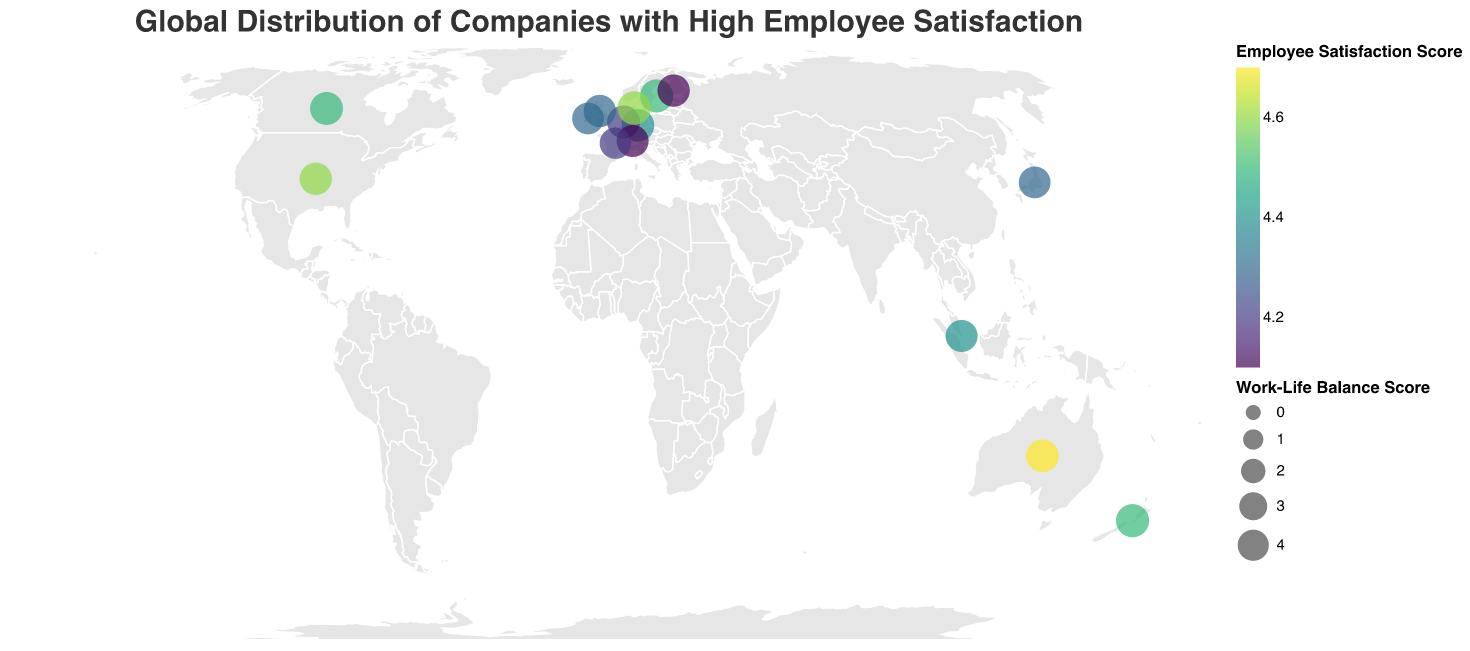What is the title of the figure? The title is typically located at the top of the plot, clearly describing the subject of the figure. Here, the title reads "Global Distribution of Companies with High Employee Satisfaction."
Answer: Global Distribution of Companies with High Employee Satisfaction How many companies are plotted in the figure? By counting the number of circles on the figure, we notice each circle represents a different company. There are 15 companies plotted in the figure.
Answer: 15 Which company has the highest Employee Satisfaction Score and what is that score? By checking the legend and color coding, we can identify that Atlassian in Australia has the highest Employee Satisfaction Score, indicated by the darkest color. The score is 4.7.
Answer: Atlassian, 4.7 Which company has the best Work-Life Balance Score and what is that score? By observing the size of the circles, we see that Lego in Denmark has the largest circle, representing the highest Work-Life Balance Score of 4.8.
Answer: Lego, 4.8 Compare the Employee Satisfaction Scores between Google and Spotify. Which one is higher? By referring to the colors of the circles for these two companies, we see that Google's circle is slightly darker than Spotify's, indicating a higher Employee Satisfaction Score. Google's score is 4.6, and Spotify's score is 4.5.
Answer: Google, 4.6 > 4.5 Which continent has the highest number of companies with high employee satisfaction as shown in the figure? By examining the geographic locations of the plotted companies, we observe that Europe has the most companies listed, with a total of seven (Sweden, Germany, Netherlands, Denmark, Switzerland, United Kingdom, and Finland).
Answer: Europe Identify the company with the lowest Employee Satisfaction Score in Europe and provide the score. By examining the colors of the circles corresponding to the companies in Europe, we see that Nestle in Switzerland has the lightest color, indicating the lowest Employee Satisfaction Score of 4.1.
Answer: Nestle, 4.1 What are the Employee Satisfaction and Work-Life Balance Scores for DBS Bank in Singapore? By hovering over the circle representing Singapore, the tooltip reveals the scores. DBS Bank has an Employee Satisfaction Score of 4.4 and a Work-Life Balance Score of 4.3.
Answer: Employee Satisfaction: 4.4, Work-Life Balance: 4.3 Which company has both high Employee Satisfaction and Work-Life Balance Scores, making it ideally balanced? By examining both the color and size of circles, we find that Lego in Denmark stands out with high scores in both categories (Employee Satisfaction: 4.6, Work-Life Balance: 4.8), indicating an ideal balance.
Answer: Lego 